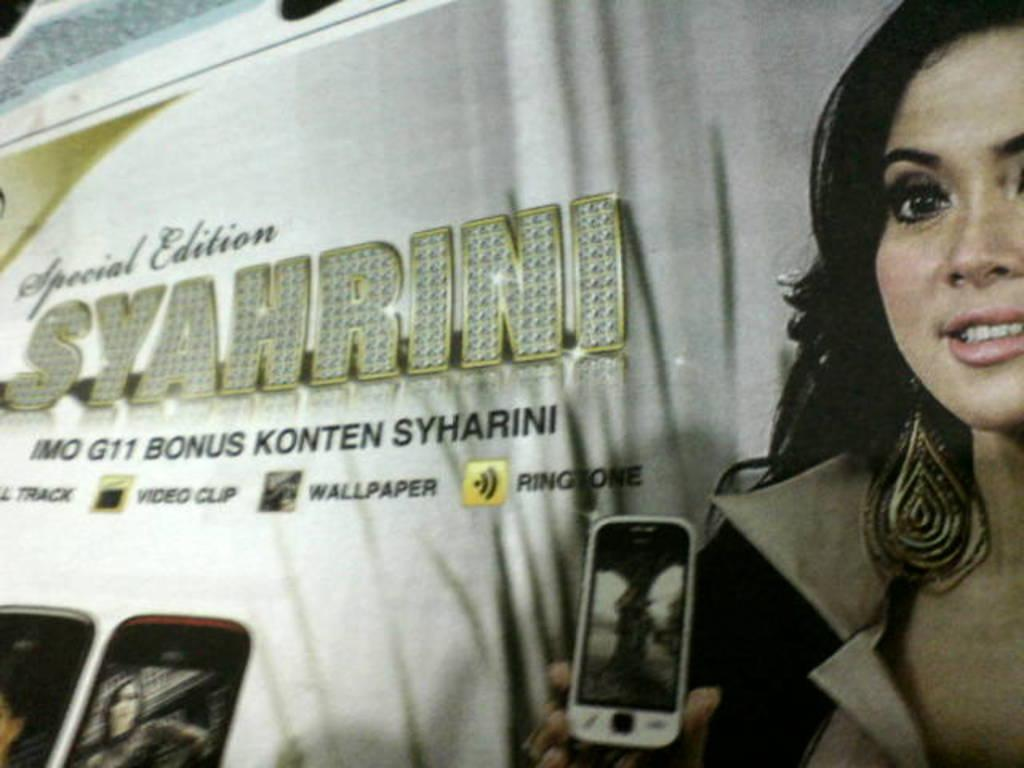What is the main object featured in the image? There is a banner in the image. What is depicted on the banner? The banner contains a picture of a lady holding a mobile. Where is the text located on the banner? There is text on the left side of the banner. What else can be seen at the bottom of the image? There are mobiles at the bottom of the image. How does the rake contribute to the pollution in the image? There is no rake present in the image, so it cannot contribute to any pollution. 